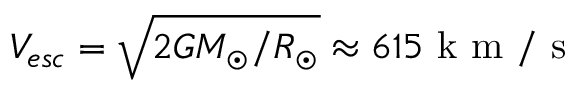<formula> <loc_0><loc_0><loc_500><loc_500>V _ { e s c } = \sqrt { 2 G M _ { \odot } / R _ { \odot } } \approx 6 1 5 k m / s</formula> 